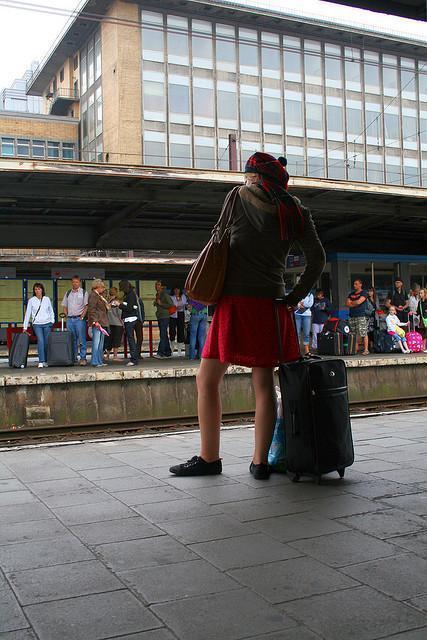What color is the suitcase held by the girl on the other side of the boarding deck to the right of the woman in the foreground?
Indicate the correct response and explain using: 'Answer: answer
Rationale: rationale.'
Options: Red, blue, pink, green. Answer: pink.
Rationale: It stands out on the screen as it is a very bright colour, which can be identified as pink. 